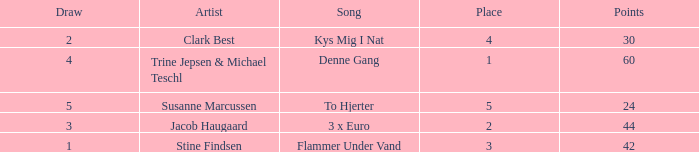What is the average Draw when the Place is larger than 5? None. 